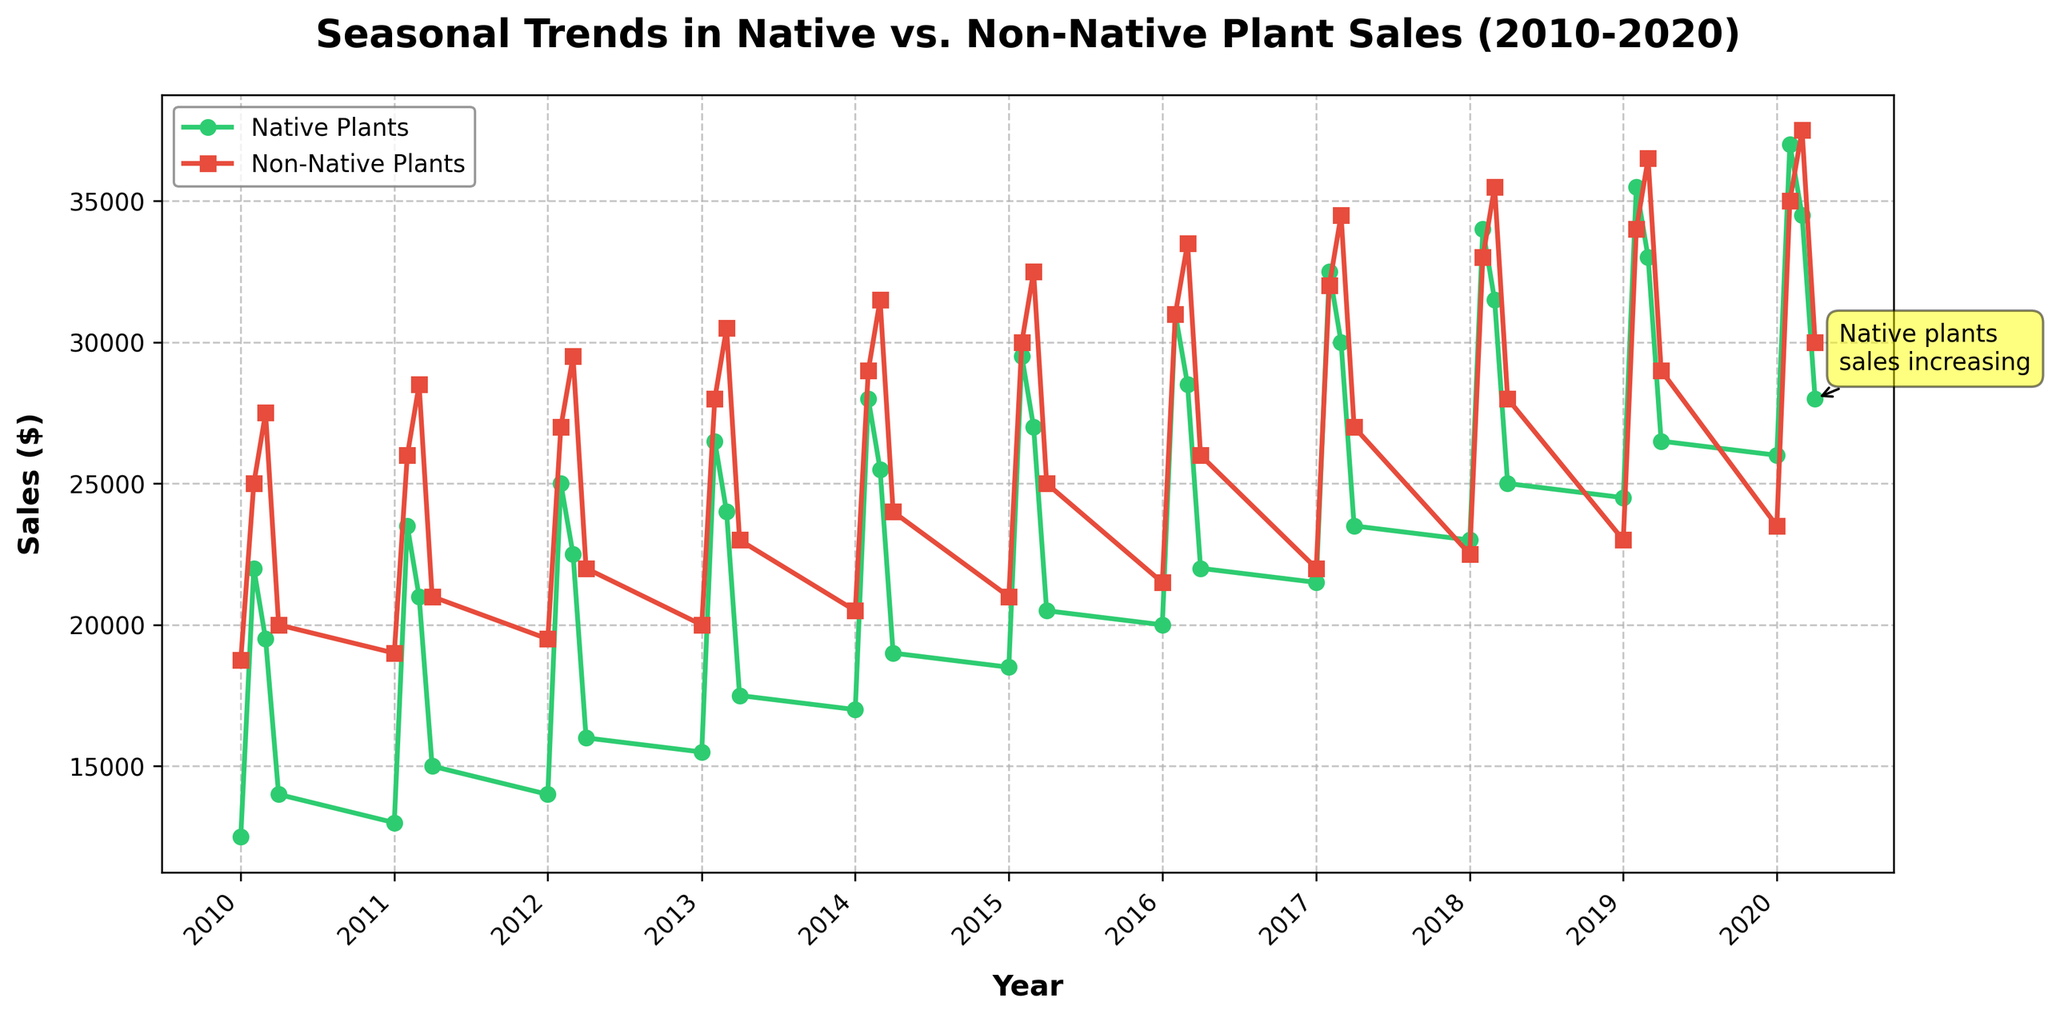What is the overall trend in the sales of native plants from 2010 to 2020? Observing the green line representing native plant sales, the trend appears to be steadily increasing over the decade. There are seasonal fluctuations, but the general direction of the line is upward.
Answer: Increasing How do the sales of non-native plants in Q3 of 2015 compare to Q3 of 2020? Look at the red line in both Q3 of 2015 and Q3 of 2020 on the x-axis. In Q3 of 2015, non-native plant sales are approximately $32,500, while in Q3 of 2020, they are approximately $37,500. This indicates an increase.
Answer: Increased In which quarter do native plants consistently have the lowest sales each year? By observing the lowest points on the green line across each year, it appears that Q1 consistently has the lowest sales for native plants.
Answer: Q1 Are there any years where the sales for native plants dropped significantly compared to the previous year? A significant drop is noticeable from Q4 of 2010 (around $14,000) to Q1 of 2011 (around $13,000), and from Q4 of 2014 (around $19,000) to Q1 of 2015 (around $18,500).
Answer: Yes What is the difference in sales of non-native plants between Q2 and Q4 of 2018? For Q2 of 2018, non-native plant sales are approximately $33,000, and for Q4 of 2018, sales are approximately $28,000. The difference is $33,000 - $28,000 = $5,000.
Answer: $5,000 During which year did native plants see the highest sales in Q2, and what was that amount? Checking the green line at Q2 across all years, native plant sales peaked in Q2 of 2020 at approximately $37,000.
Answer: 2020, $37,000 Between 2013 and 2017, how do native and non-native plant sales compare in Q4? By examining the green and red lines in Q4 from 2013 to 2017, native plant sales are generally lower compared to non-native plant sales. In all Q4's, non-native plants consistently have higher sales.
Answer: Non-native plants higher Which type of plant, native or non-native, showed a closer sales value to each other in Q1 of any given year, and when? Focusing on Q1 sales, in Q1 of 2018, native plant sales were approximately $23,000 and non-native plant sales were about $22,500, showing the closest values.
Answer: Q1 of 2018 What is the average sales of non-native plants in Q3 across all years? Add up the non-native plant sales in Q3 for all years and divide by the number of years. The sum is $27,500 + $28,500 + $29,500 + $30,500 + $31,500 + $32,500 + $33,500 + $34,500 + $35,500 + $36,500 + $37,500 = $357,000. There are 11 years, so $357,000 / 11 = $32,454.55.
Answer: $32,454.55 Which year shows the smallest difference in sales between native and non-native plants in Q4? Observing Q4 data points and calculating the differences, the smallest difference appears in Q4 of 2019, where native plant sales are approximately $26,500 and non-native plant sales are $29,000. The difference is $2,500 which is the smallest observed.
Answer: 2019 